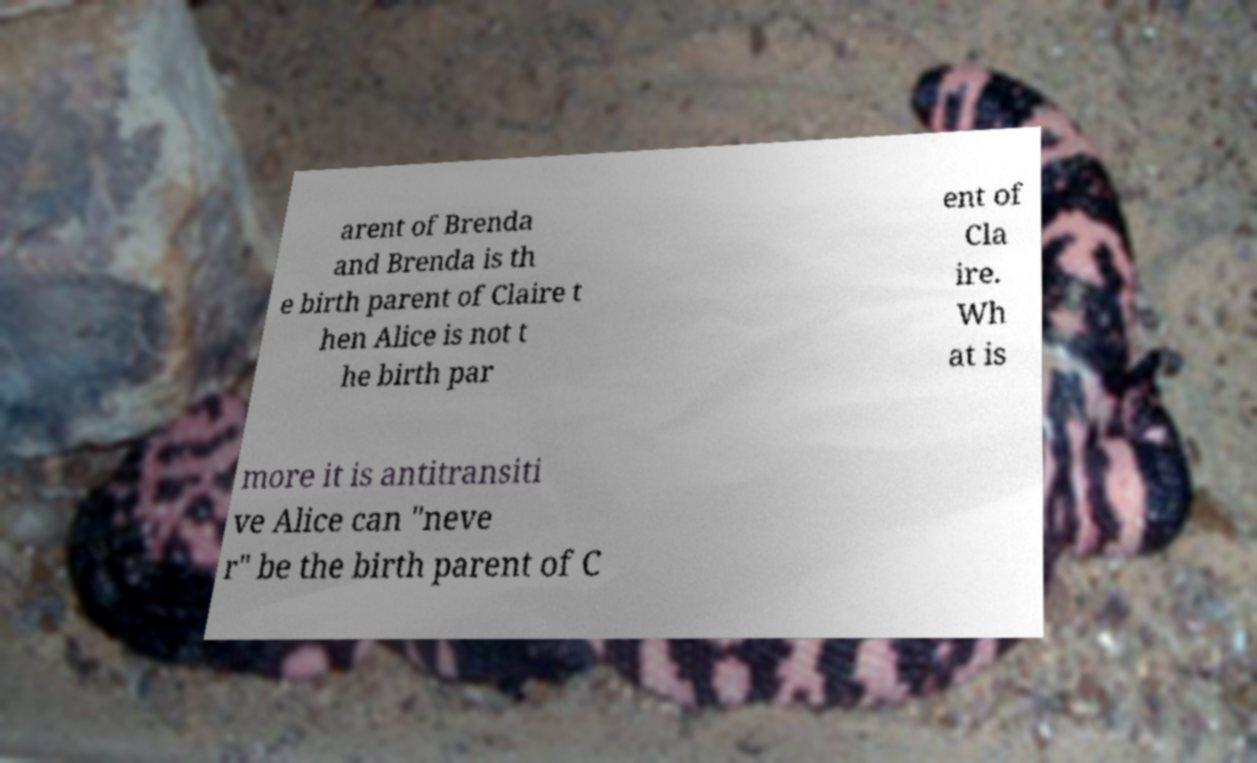What messages or text are displayed in this image? I need them in a readable, typed format. arent of Brenda and Brenda is th e birth parent of Claire t hen Alice is not t he birth par ent of Cla ire. Wh at is more it is antitransiti ve Alice can "neve r" be the birth parent of C 